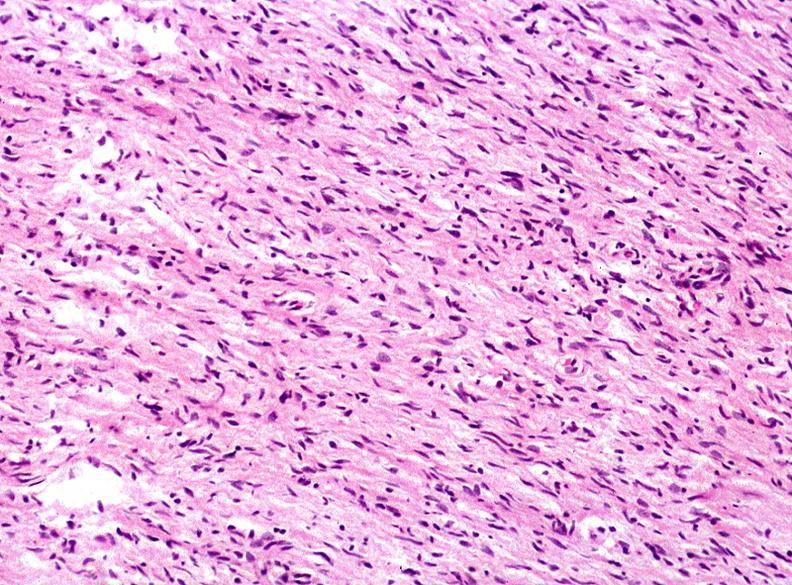does papillary adenoma show skin, neurofibromatosis?
Answer the question using a single word or phrase. No 